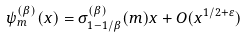Convert formula to latex. <formula><loc_0><loc_0><loc_500><loc_500>\psi _ { m } ^ { ( \beta ) } ( x ) = \sigma _ { 1 - 1 / \beta } ^ { ( \beta ) } ( m ) x + O ( { x ^ { 1 / 2 + \varepsilon } } )</formula> 